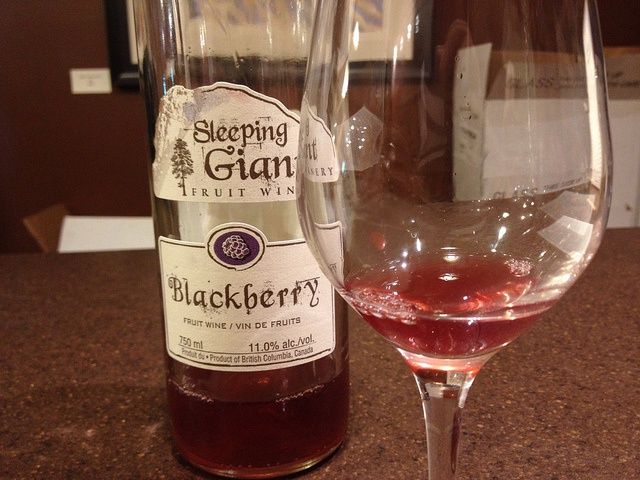Describe the objects in this image and their specific colors. I can see dining table in maroon, brown, black, and tan tones, wine glass in maroon, gray, and brown tones, and bottle in maroon, black, and tan tones in this image. 